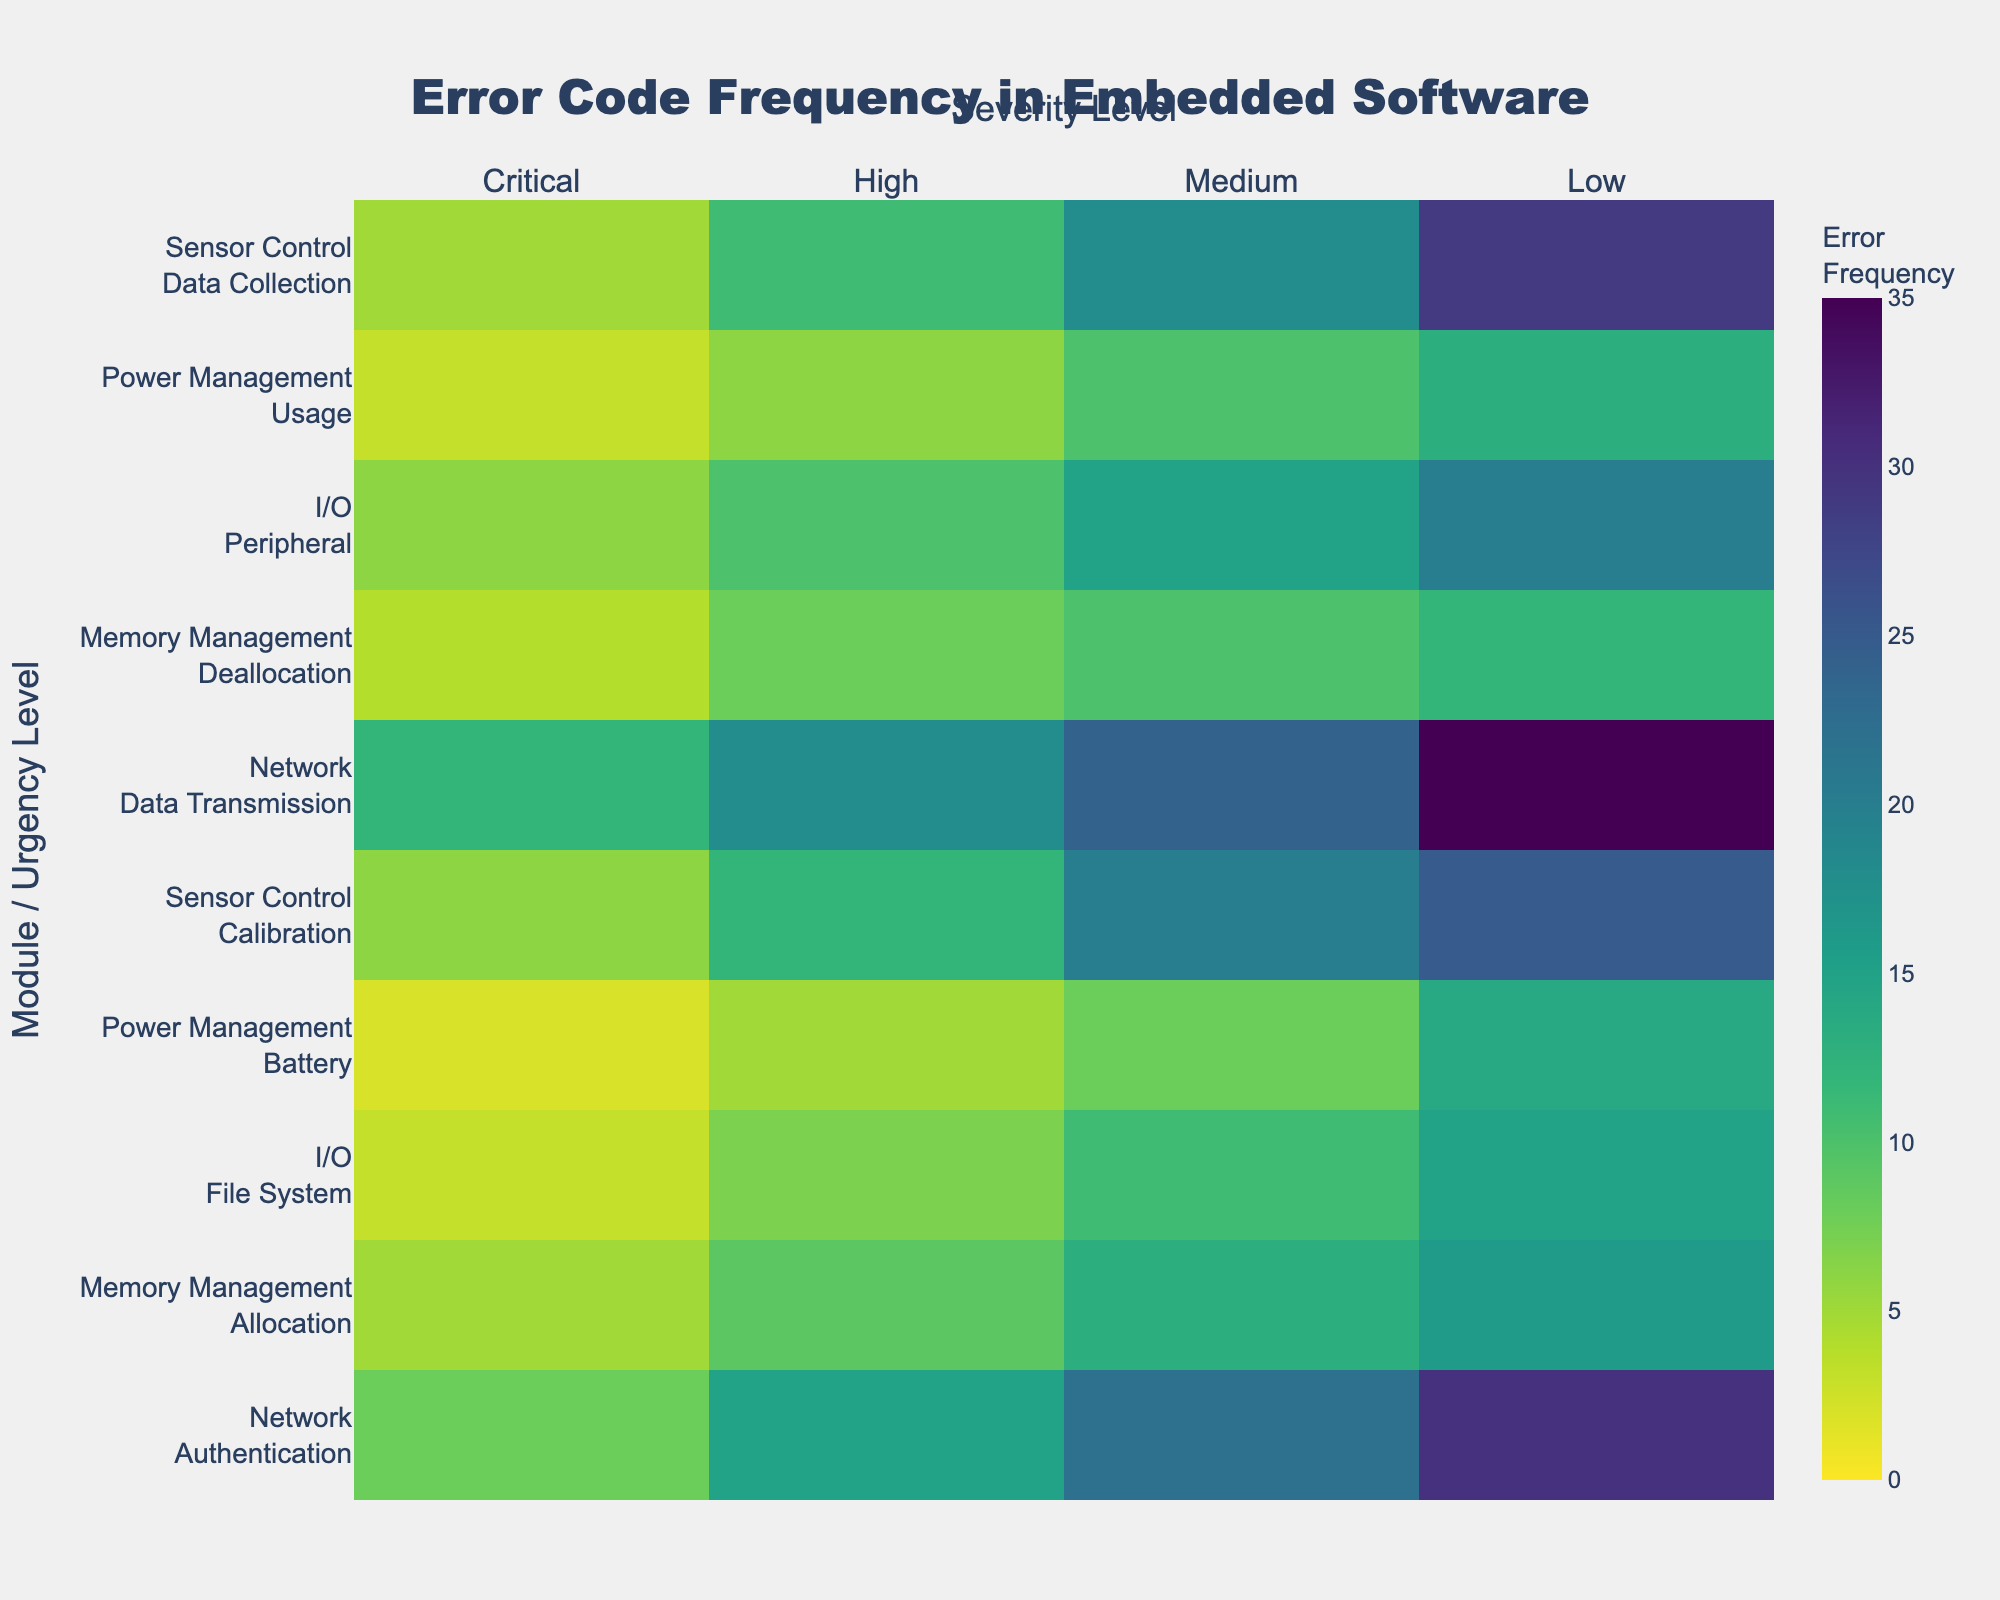What is the title of the heatmap? The title of the heatmap is displayed at the top of the figure as "Error Code Frequency in Embedded Software".
Answer: Error Code Frequency in Embedded Software Which severity level has the highest color intensity? The color intensity represents higher frequencies, and from the Viridis color scale, the highest intensity corresponds to the 'Low' severity level with the brightest yellow color.
Answer: Low Which module and urgency level combination has the highest error frequency? By looking at the brightest cell in the heatmap, the "Network" module with "Data Transmission" urgency level combination has the highest error frequency.
Answer: Network, Data Transmission What is the total number of critical errors across all modules? Sum the 'Critical' column values: 8 + 5 + 3 + 2 + 6 + 12 + 4 + 6 + 3 + 5 = 54.
Answer: 54 How does the error frequency for Memory Management in 'Allocation' compare to 'Deallocation' for medium severity? Compare the values for Memory Management: 'Allocation' has 13 and 'Deallocation' has 10 for medium severity.
Answer: Allocation has a higher value than Deallocation How many unique modules and urgency levels are shown on the y-axis? The figure represents combinations of modules and urgency levels, totaling 10 unique y-axis labels.
Answer: 10 Which combination has fewer errors: I/O File System with High urgency or Sensor Control Calibration with Medium urgency? Compare the error counts: I/O File System with High urgency has 7, whereas Sensor Control Calibration with Medium urgency has 20.
Answer: I/O File System with High urgency What is the average error frequency for the 'Power Management' module across all urgency levels? Calculate the average by summing all values and dividing by the number of values: (2+5+8+14+3+6+10+13) / 4 urgency levels = 63 / 4 = 15.75.
Answer: 15.75 Which module has the most pronounced discrepancy between urgent levels? By observing the range of colors, the "Network" module shows a significant discrepancy especially visible in 'Data Transmission'.
Answer: Network 